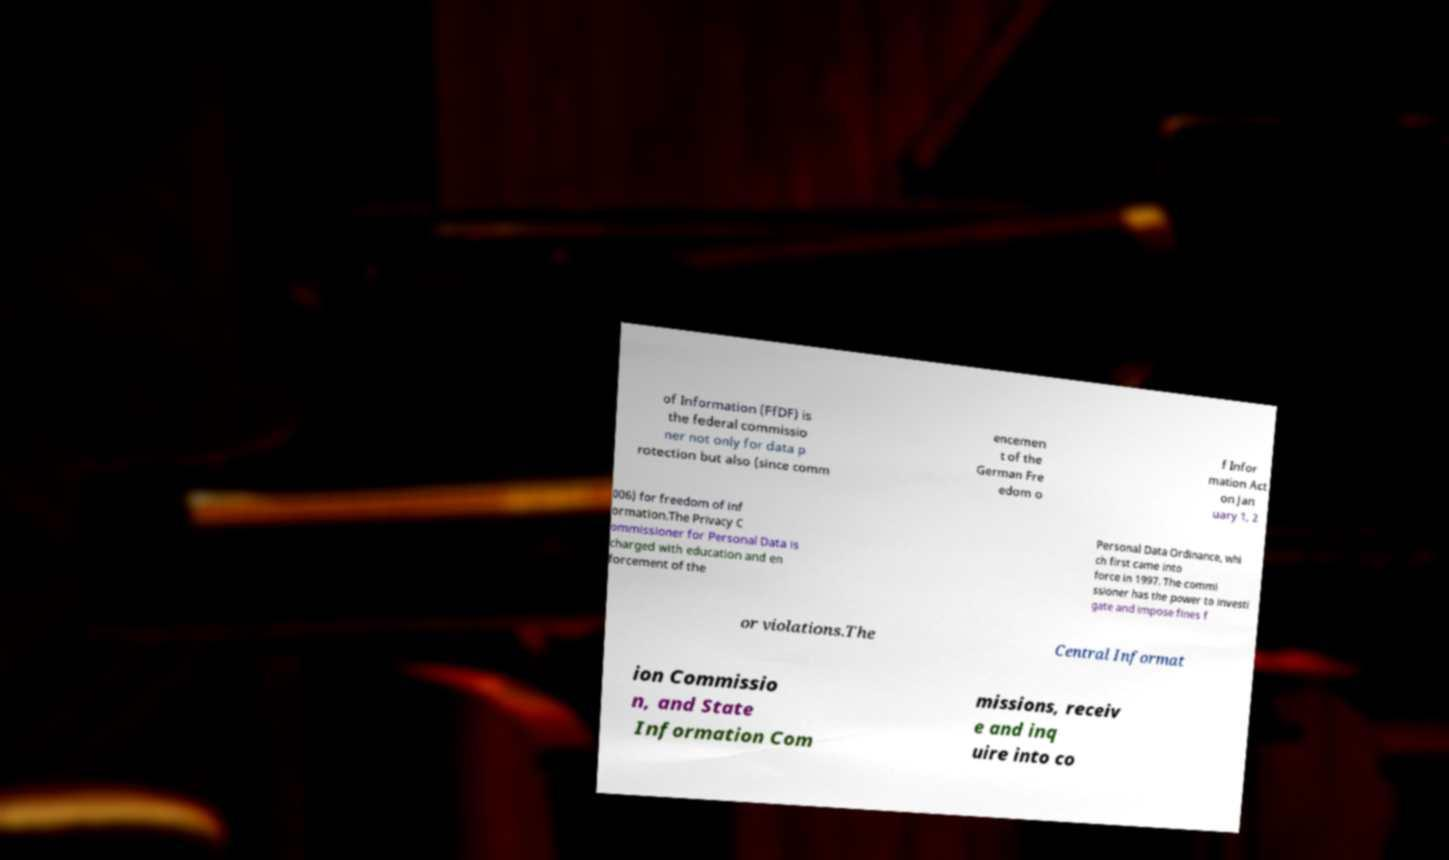Could you extract and type out the text from this image? of Information (FfDF) is the federal commissio ner not only for data p rotection but also (since comm encemen t of the German Fre edom o f Infor mation Act on Jan uary 1, 2 006) for freedom of inf ormation.The Privacy C ommissioner for Personal Data is charged with education and en forcement of the Personal Data Ordinance, whi ch first came into force in 1997. The commi ssioner has the power to investi gate and impose fines f or violations.The Central Informat ion Commissio n, and State Information Com missions, receiv e and inq uire into co 